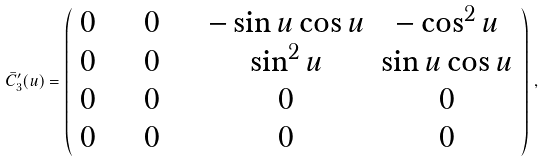Convert formula to latex. <formula><loc_0><loc_0><loc_500><loc_500>\bar { C } _ { 3 } ^ { \prime } ( u ) = \left ( \begin{array} { c c c c } 0 & \quad 0 & \quad - \sin u \cos u & - \cos ^ { 2 } u \\ 0 & \quad 0 & \quad \sin ^ { 2 } u & \sin u \cos u \\ 0 & \quad 0 & \quad 0 & 0 \\ 0 & \quad 0 & \quad 0 & 0 \end{array} \right ) \, ,</formula> 